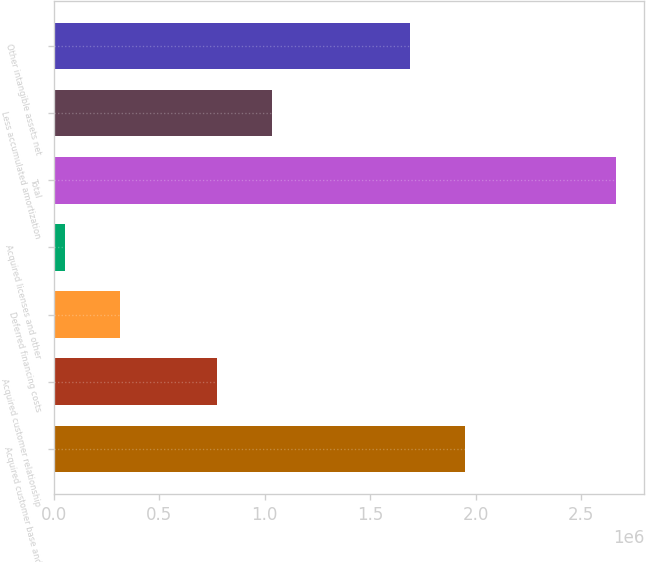<chart> <loc_0><loc_0><loc_500><loc_500><bar_chart><fcel>Acquired customer base and<fcel>Acquired customer relationship<fcel>Deferred financing costs<fcel>Acquired licenses and other<fcel>Total<fcel>Less accumulated amortization<fcel>Other intangible assets net<nl><fcel>1.9476e+06<fcel>775000<fcel>315030<fcel>53866<fcel>2.66551e+06<fcel>1.03616e+06<fcel>1.68643e+06<nl></chart> 